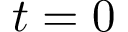<formula> <loc_0><loc_0><loc_500><loc_500>t = 0</formula> 